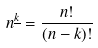Convert formula to latex. <formula><loc_0><loc_0><loc_500><loc_500>n ^ { \underline { k } } = \frac { n ! } { ( n - k ) ! }</formula> 